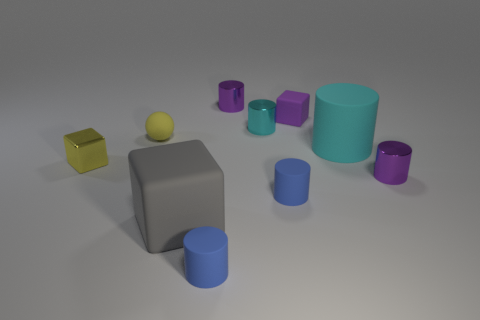Do the yellow object that is behind the small yellow cube and the small blue object that is in front of the gray matte cube have the same material?
Provide a short and direct response. Yes. Is the number of large cyan cylinders left of the tiny purple rubber cube the same as the number of blue cylinders left of the cyan shiny object?
Provide a short and direct response. No. What color is the cylinder that is the same size as the gray thing?
Provide a succinct answer. Cyan. Is there a tiny shiny block of the same color as the small rubber sphere?
Your answer should be compact. Yes. How many objects are things on the right side of the yellow shiny thing or blue cylinders?
Make the answer very short. 9. How many other things are the same size as the cyan metal thing?
Provide a succinct answer. 7. What material is the tiny purple cylinder that is behind the metal cylinder in front of the matte thing to the left of the gray rubber object?
Give a very brief answer. Metal. How many cylinders are big cyan rubber objects or yellow objects?
Provide a succinct answer. 1. Is there any other thing that is the same shape as the yellow rubber thing?
Your answer should be compact. No. Is the number of yellow rubber balls that are in front of the yellow shiny object greater than the number of small purple objects that are in front of the tiny cyan shiny thing?
Keep it short and to the point. No. 